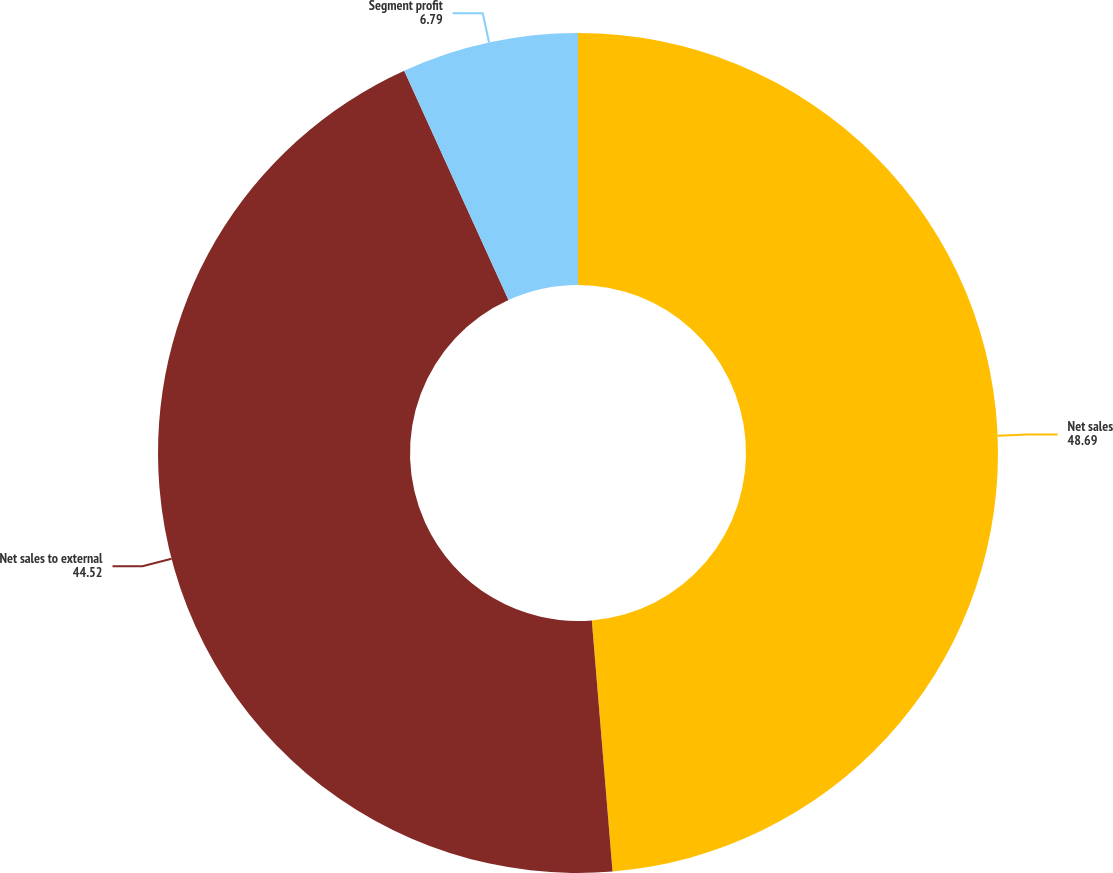Convert chart to OTSL. <chart><loc_0><loc_0><loc_500><loc_500><pie_chart><fcel>Net sales<fcel>Net sales to external<fcel>Segment profit<nl><fcel>48.69%<fcel>44.52%<fcel>6.79%<nl></chart> 